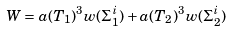Convert formula to latex. <formula><loc_0><loc_0><loc_500><loc_500>W = a ( T _ { 1 } ) ^ { 3 } w ( \Sigma _ { 1 } ^ { i } ) + a ( T _ { 2 } ) ^ { 3 } w ( \Sigma _ { 2 } ^ { i } )</formula> 